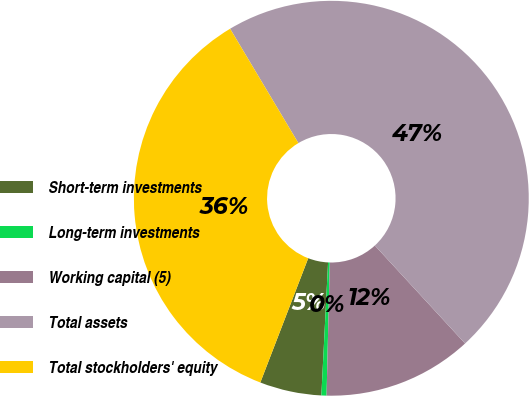<chart> <loc_0><loc_0><loc_500><loc_500><pie_chart><fcel>Short-term investments<fcel>Long-term investments<fcel>Working capital (5)<fcel>Total assets<fcel>Total stockholders' equity<nl><fcel>5.05%<fcel>0.42%<fcel>12.23%<fcel>46.72%<fcel>35.58%<nl></chart> 